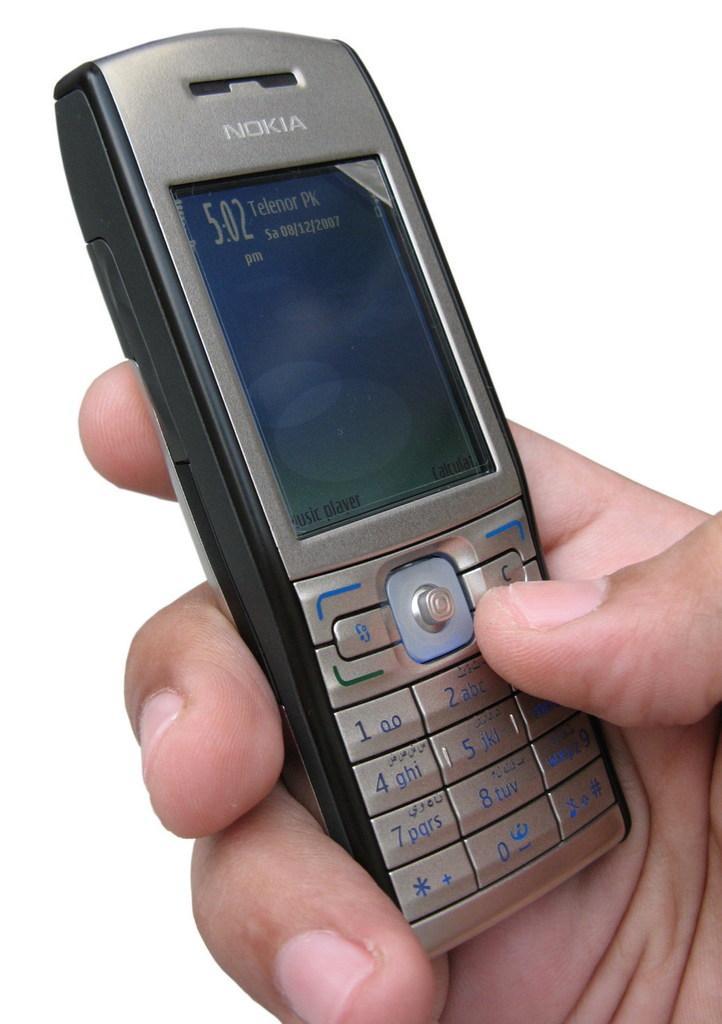Could you give a brief overview of what you see in this image? In the center of the image a person hand and a mobile is there. 